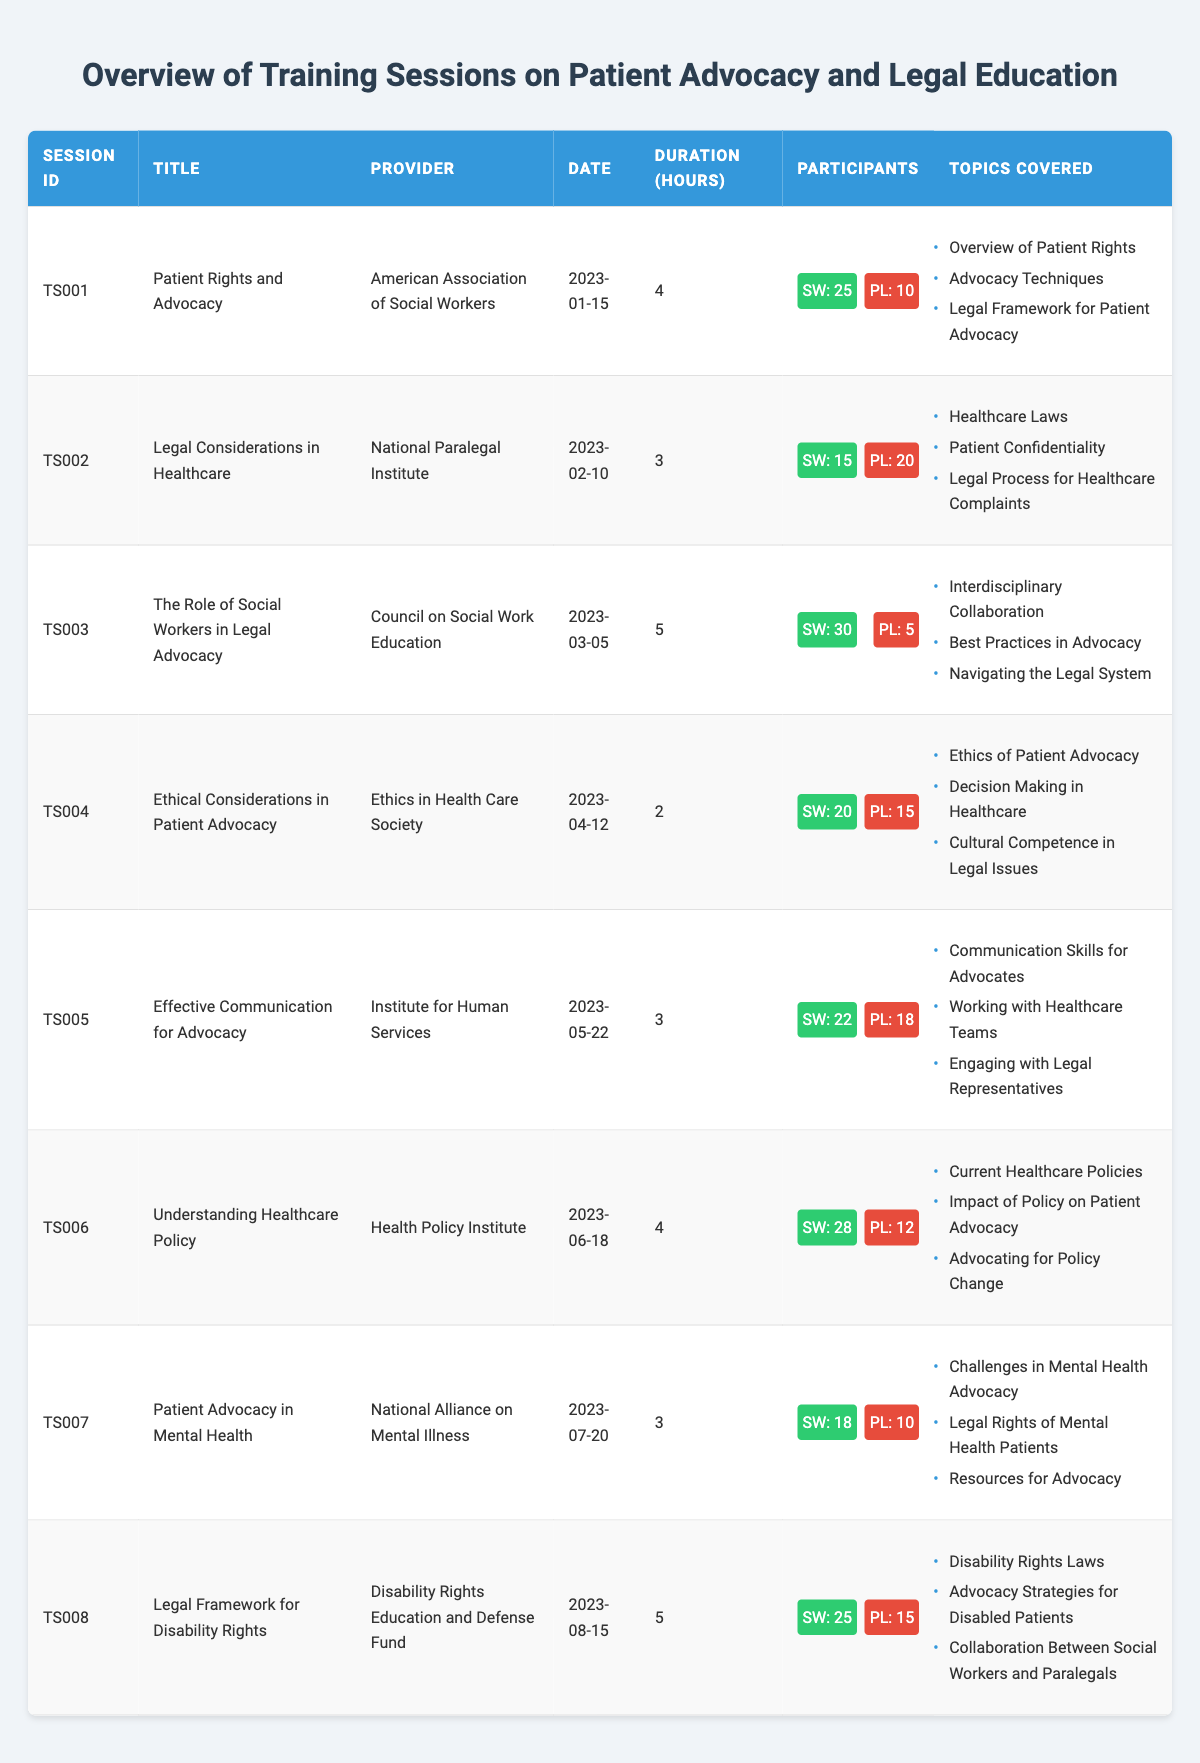What is the title of the training session taking place on February 10, 2023? The date February 10, 2023, corresponds to the training session titled "Legal Considerations in Healthcare," as indicated in that row of the table.
Answer: Legal Considerations in Healthcare How many social workers participated in the training session on April 12, 2023? Referring to the row for the training session on April 12, 2023, it shows that 20 social workers participated in that session.
Answer: 20 Which provider offered the training session regarding the ethical considerations in patient advocacy? The table indicates that the training session on ethical considerations in patient advocacy was provided by the Ethics in Health Care Society.
Answer: Ethics in Health Care Society What is the total duration of the training sessions conducted in January and February 2023? The duration of the training session on January 15, 2023, is 4 hours, and for February 10, 2023, it is 3 hours. Summing these gives us 4 + 3 = 7.
Answer: 7 How many paralegals participated in the session titled "Patient Advocacy in Mental Health"? The session titled "Patient Advocacy in Mental Health" had 10 paralegals participating, as shown in that row of the table.
Answer: 10 Which training session covered the topic "Disability Rights Laws"? The training session that covered the topic "Disability Rights Laws" is titled "Legal Framework for Disability Rights," as seen in the corresponding row of the table.
Answer: Legal Framework for Disability Rights What was the average duration of all training sessions listed in the table? The durations of the training sessions are 4, 3, 5, 2, 3, 4, 3, and 5 hours. To find the average, sum these values: 4+3+5+2+3+4+3+5 = 29, then divide by the number of sessions (8): 29/8 = 3.625.
Answer: 3.625 Is there a training session that had more paralegals than social workers? Yes, during the session on February 10, 2023, there were 20 paralegals and only 15 social workers, which confirms the fact that this session had more paralegals.
Answer: Yes How many total participants attended the "Effective Communication for Advocacy" session? The session on "Effective Communication for Advocacy" had 22 social workers and 18 paralegals. Adding these together gives 22 + 18 = 40 total participants.
Answer: 40 Which provider had the maximum number of social worker participation in a single session? The highest number of social workers participated in the session titled "The Role of Social Workers in Legal Advocacy," with 30 attendees, as indicated in that row.
Answer: Council on Social Work Education 